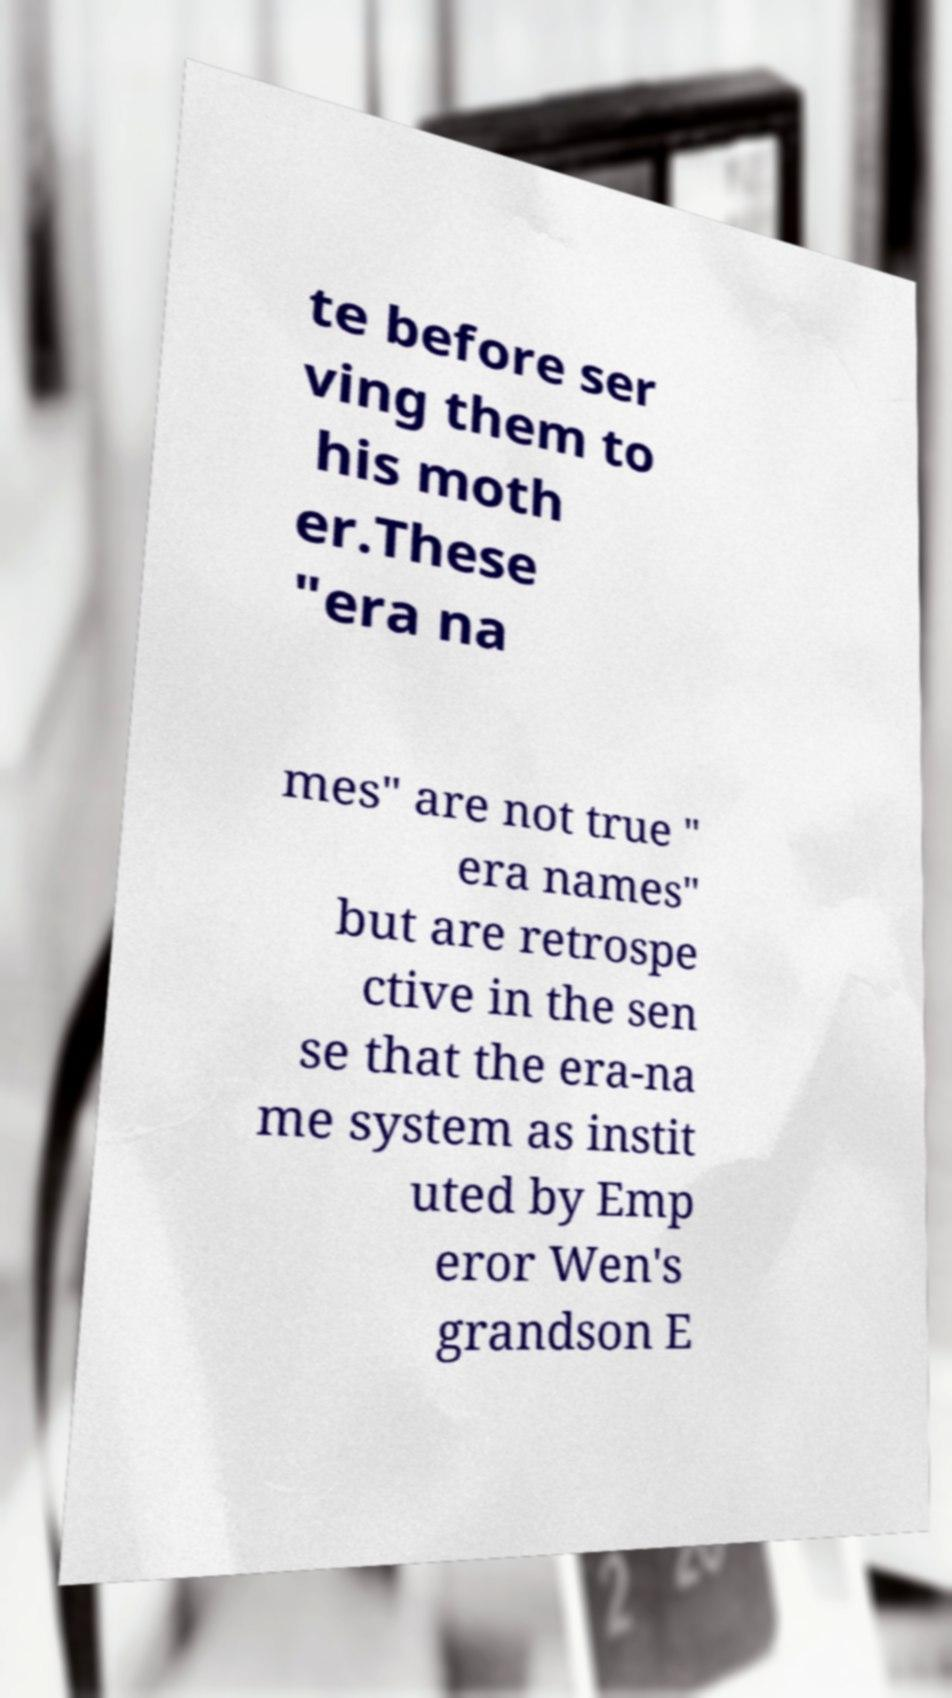Please identify and transcribe the text found in this image. te before ser ving them to his moth er.These "era na mes" are not true " era names" but are retrospe ctive in the sen se that the era-na me system as instit uted by Emp eror Wen's grandson E 